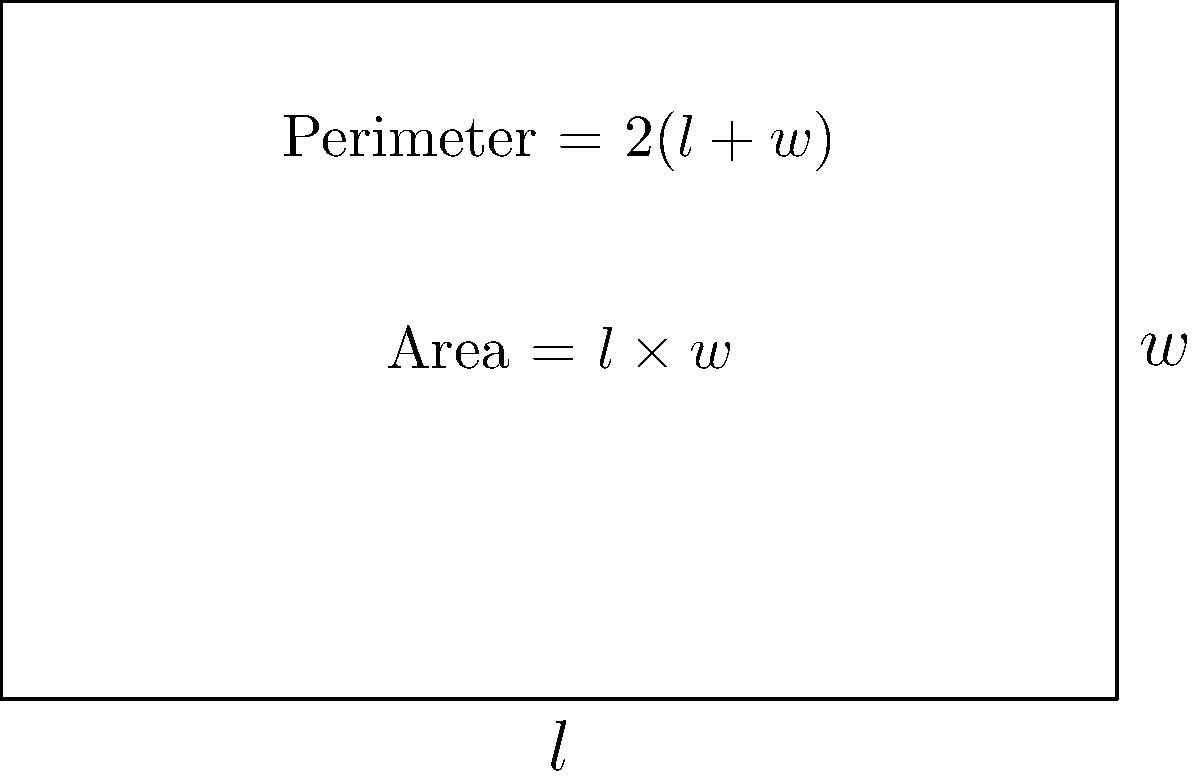As a hotel room designer, you need to maximize the area of a rectangular room while adhering to building constraints. The total perimeter of the room must be 26 meters. What should be the length and width of the room to achieve the maximum possible area, and what is this maximum area? Let's approach this step-by-step:

1) Let $l$ be the length and $w$ be the width of the room.

2) Given that the perimeter is 26 meters, we can write:
   $2l + 2w = 26$
   $l + w = 13$

3) We can express $w$ in terms of $l$:
   $w = 13 - l$

4) The area of the room is given by $A = l \times w$
   Substituting $w$:
   $A = l(13 - l) = 13l - l^2$

5) To find the maximum area, we need to find where the derivative of $A$ with respect to $l$ is zero:
   $\frac{dA}{dl} = 13 - 2l$
   Set this to zero: $13 - 2l = 0$
   Solve: $l = 6.5$

6) Since $l + w = 13$, if $l = 6.5$, then $w$ must also be 6.5.

7) To confirm this is a maximum, we can check the second derivative:
   $\frac{d^2A}{dl^2} = -2$, which is negative, confirming a maximum.

8) The maximum area is therefore:
   $A = 6.5 \times 6.5 = 42.25$ square meters

Therefore, the room should be a square with both length and width equal to 6.5 meters, giving a maximum area of 42.25 square meters.
Answer: Length = 6.5m, Width = 6.5m, Maximum Area = 42.25m² 